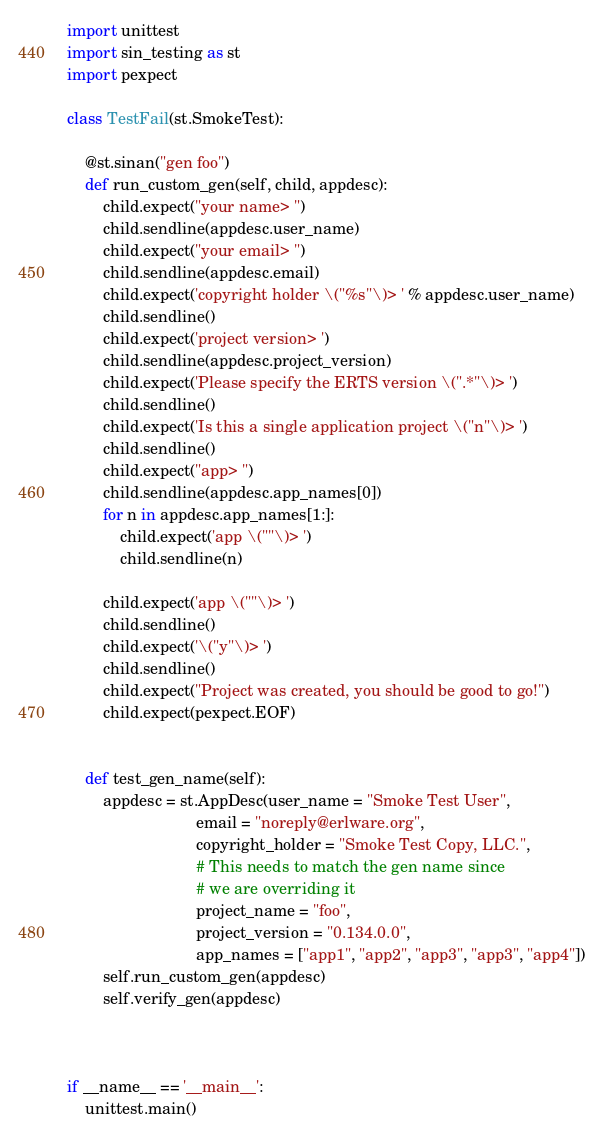Convert code to text. <code><loc_0><loc_0><loc_500><loc_500><_Python_>import unittest
import sin_testing as st
import pexpect

class TestFail(st.SmokeTest):

    @st.sinan("gen foo")
    def run_custom_gen(self, child, appdesc):
        child.expect("your name> ")
        child.sendline(appdesc.user_name)
        child.expect("your email> ")
        child.sendline(appdesc.email)
        child.expect('copyright holder \("%s"\)> ' % appdesc.user_name)
        child.sendline()
        child.expect('project version> ')
        child.sendline(appdesc.project_version)
        child.expect('Please specify the ERTS version \(".*"\)> ')
        child.sendline()
        child.expect('Is this a single application project \("n"\)> ')
        child.sendline()
        child.expect("app> ")
        child.sendline(appdesc.app_names[0])
        for n in appdesc.app_names[1:]:
            child.expect('app \(""\)> ')
            child.sendline(n)

        child.expect('app \(""\)> ')
        child.sendline()
        child.expect('\("y"\)> ')
        child.sendline()
        child.expect("Project was created, you should be good to go!")
        child.expect(pexpect.EOF)


    def test_gen_name(self):
        appdesc = st.AppDesc(user_name = "Smoke Test User",
                             email = "noreply@erlware.org",
                             copyright_holder = "Smoke Test Copy, LLC.",
                             # This needs to match the gen name since
                             # we are overriding it
                             project_name = "foo",
                             project_version = "0.134.0.0",
                             app_names = ["app1", "app2", "app3", "app3", "app4"])
        self.run_custom_gen(appdesc)
        self.verify_gen(appdesc)



if __name__ == '__main__':
    unittest.main()
</code> 